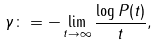<formula> <loc_0><loc_0><loc_500><loc_500>\gamma \colon = - \lim _ { t \rightarrow \infty } \frac { \log P ( t ) } { t } ,</formula> 